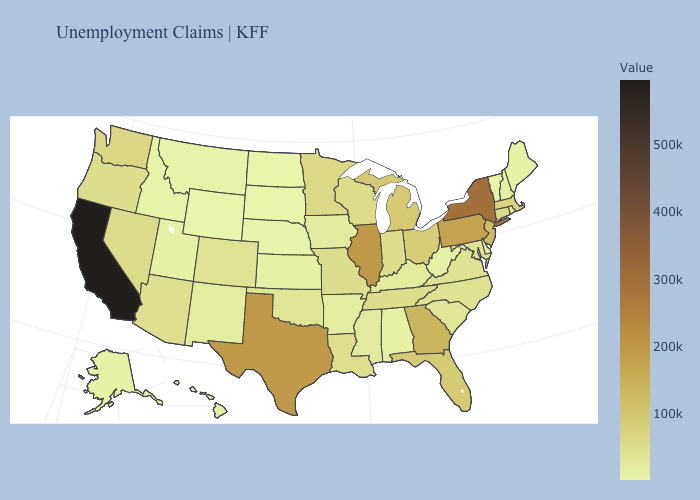Among the states that border Montana , does North Dakota have the highest value?
Write a very short answer. No. Does California have the highest value in the USA?
Write a very short answer. Yes. Among the states that border Oregon , does Idaho have the lowest value?
Concise answer only. Yes. Which states hav the highest value in the Northeast?
Concise answer only. New York. Does Ohio have the highest value in the MidWest?
Keep it brief. No. Which states have the lowest value in the USA?
Be succinct. South Dakota. 